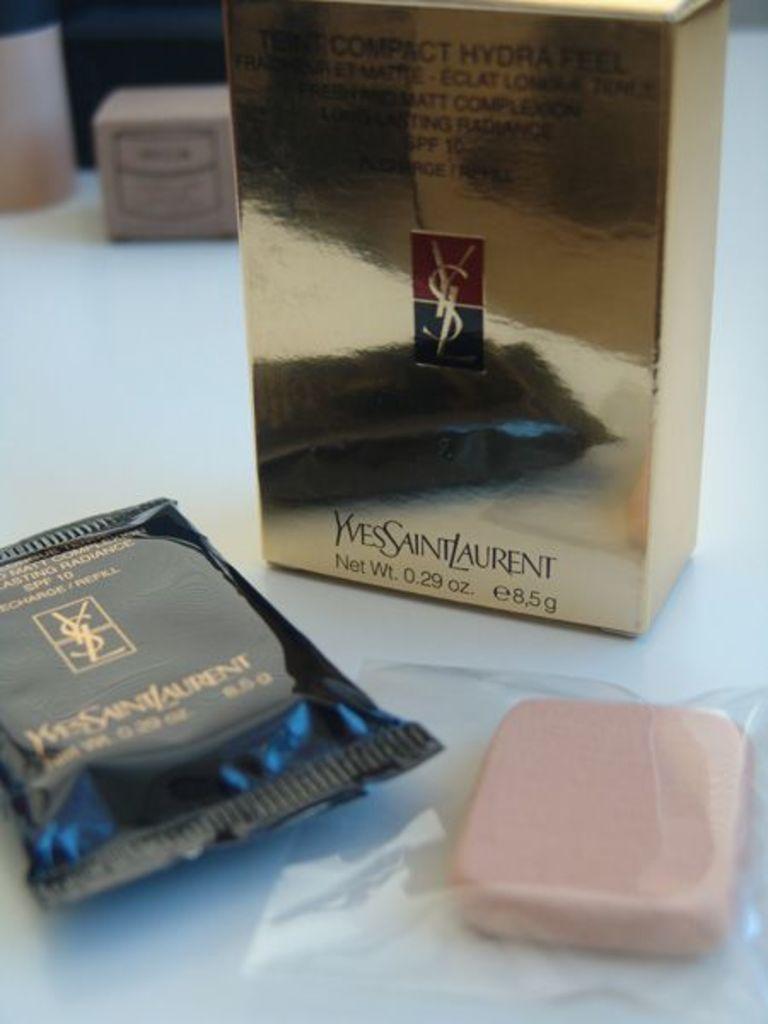What brand is shown for this product?
Offer a very short reply. Yves saint laurent. How much does the product weigh?
Ensure brevity in your answer.  .29 oz. 